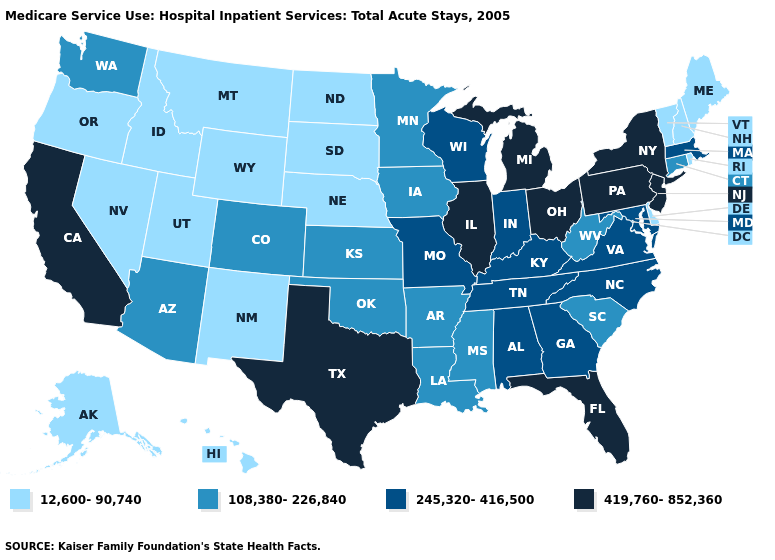What is the lowest value in the West?
Short answer required. 12,600-90,740. Which states have the lowest value in the USA?
Keep it brief. Alaska, Delaware, Hawaii, Idaho, Maine, Montana, Nebraska, Nevada, New Hampshire, New Mexico, North Dakota, Oregon, Rhode Island, South Dakota, Utah, Vermont, Wyoming. What is the value of Connecticut?
Keep it brief. 108,380-226,840. Name the states that have a value in the range 108,380-226,840?
Answer briefly. Arizona, Arkansas, Colorado, Connecticut, Iowa, Kansas, Louisiana, Minnesota, Mississippi, Oklahoma, South Carolina, Washington, West Virginia. Does Texas have the lowest value in the USA?
Keep it brief. No. What is the value of Nebraska?
Short answer required. 12,600-90,740. Does Indiana have the highest value in the MidWest?
Short answer required. No. Which states have the lowest value in the Northeast?
Short answer required. Maine, New Hampshire, Rhode Island, Vermont. Does Maine have a higher value than Nebraska?
Answer briefly. No. Name the states that have a value in the range 108,380-226,840?
Quick response, please. Arizona, Arkansas, Colorado, Connecticut, Iowa, Kansas, Louisiana, Minnesota, Mississippi, Oklahoma, South Carolina, Washington, West Virginia. Among the states that border Washington , which have the highest value?
Answer briefly. Idaho, Oregon. Among the states that border Washington , which have the highest value?
Give a very brief answer. Idaho, Oregon. Name the states that have a value in the range 12,600-90,740?
Keep it brief. Alaska, Delaware, Hawaii, Idaho, Maine, Montana, Nebraska, Nevada, New Hampshire, New Mexico, North Dakota, Oregon, Rhode Island, South Dakota, Utah, Vermont, Wyoming. Name the states that have a value in the range 419,760-852,360?
Give a very brief answer. California, Florida, Illinois, Michigan, New Jersey, New York, Ohio, Pennsylvania, Texas. What is the value of Florida?
Keep it brief. 419,760-852,360. 